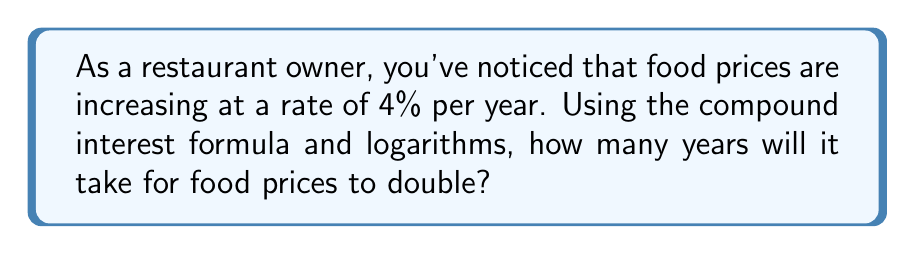Could you help me with this problem? Let's approach this step-by-step:

1) The compound interest formula is:
   $$A = P(1 + r)^t$$
   where A is the final amount, P is the initial amount, r is the rate, and t is time.

2) We want to find when the price doubles, so:
   $$2P = P(1 + 0.04)^t$$

3) Simplify by dividing both sides by P:
   $$2 = (1.04)^t$$

4) To solve for t, we need to use logarithms. Let's use natural log (ln):
   $$\ln(2) = \ln((1.04)^t)$$

5) Using the logarithm property $\ln(a^b) = b\ln(a)$:
   $$\ln(2) = t\ln(1.04)$$

6) Solve for t:
   $$t = \frac{\ln(2)}{\ln(1.04)}$$

7) Calculate:
   $$t = \frac{0.6931}{0.0392} \approx 17.673$$

8) Round to the nearest year:
   $$t \approx 18\text{ years}$$
Answer: 18 years 